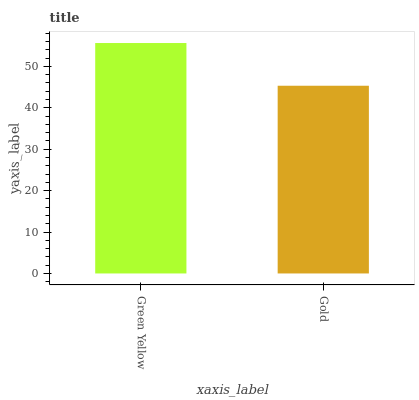Is Gold the minimum?
Answer yes or no. Yes. Is Green Yellow the maximum?
Answer yes or no. Yes. Is Gold the maximum?
Answer yes or no. No. Is Green Yellow greater than Gold?
Answer yes or no. Yes. Is Gold less than Green Yellow?
Answer yes or no. Yes. Is Gold greater than Green Yellow?
Answer yes or no. No. Is Green Yellow less than Gold?
Answer yes or no. No. Is Green Yellow the high median?
Answer yes or no. Yes. Is Gold the low median?
Answer yes or no. Yes. Is Gold the high median?
Answer yes or no. No. Is Green Yellow the low median?
Answer yes or no. No. 